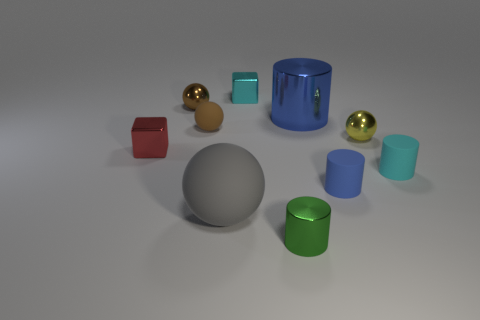Are there fewer red spheres than tiny yellow objects?
Your answer should be very brief. Yes. What color is the large object that is on the left side of the metallic cylinder to the right of the green cylinder?
Your answer should be compact. Gray. What material is the large object that is the same shape as the tiny brown matte thing?
Your response must be concise. Rubber. How many matte objects are purple blocks or red objects?
Provide a short and direct response. 0. Are the small cylinder left of the blue matte cylinder and the sphere that is in front of the tiny blue object made of the same material?
Give a very brief answer. No. Is there a brown thing?
Keep it short and to the point. Yes. There is a blue thing that is behind the yellow object; does it have the same shape as the metallic thing that is in front of the big rubber object?
Make the answer very short. Yes. Are there any cyan things that have the same material as the gray sphere?
Your answer should be very brief. Yes. Do the tiny cylinder in front of the blue rubber cylinder and the red block have the same material?
Your answer should be compact. Yes. Is the number of cylinders that are behind the red metal block greater than the number of small blue objects in front of the green cylinder?
Provide a short and direct response. Yes. 